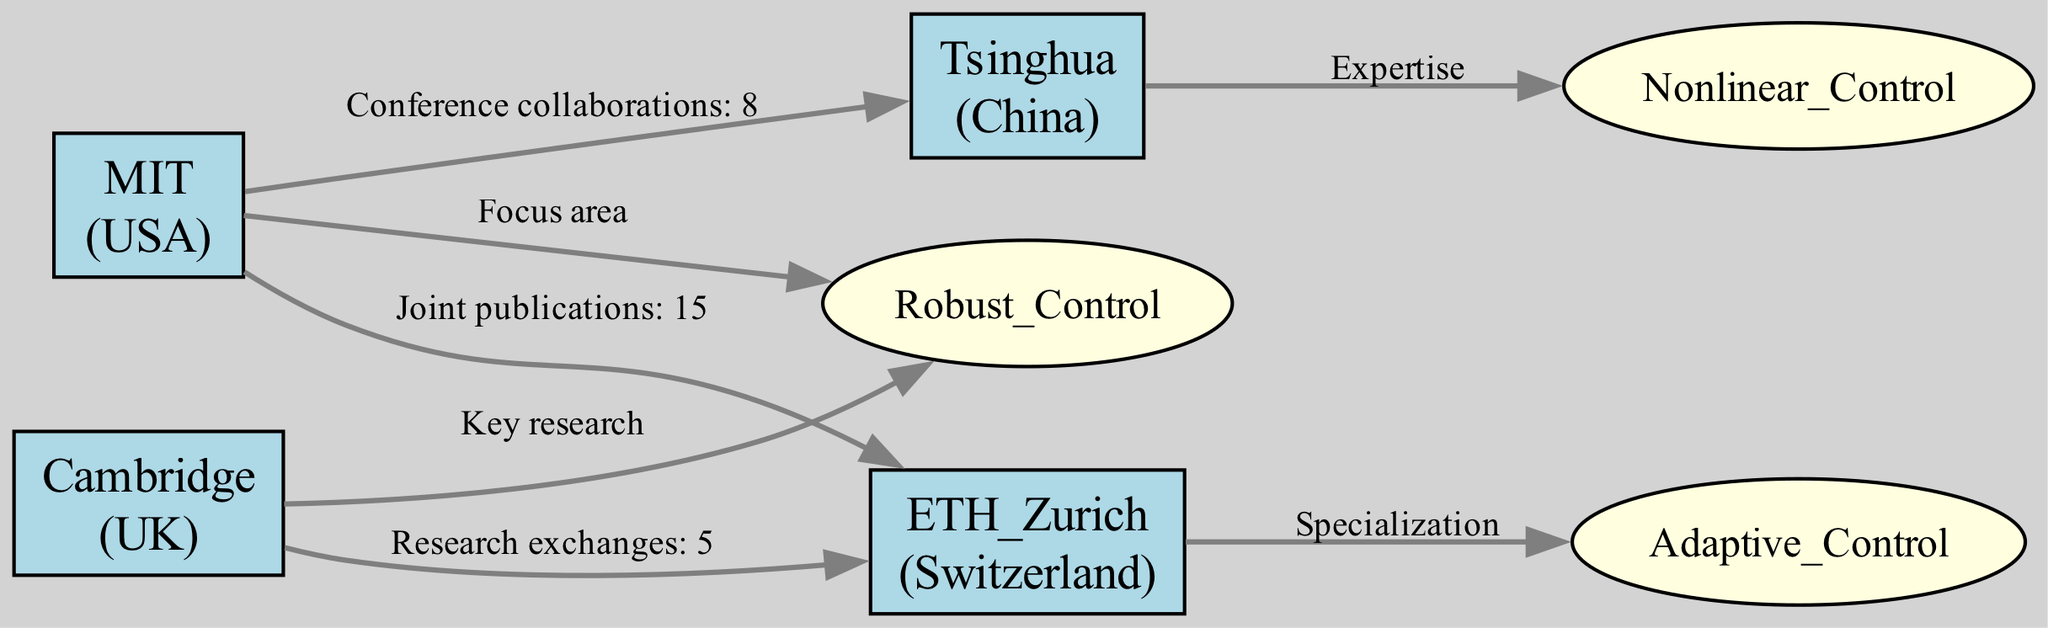What is the total number of universities represented in the diagram? There are four nodes labeled as universities: MIT, ETH Zurich, Tsinghua, and Cambridge. Counting these gives a total of 4 universities.
Answer: 4 Which university has the highest number of joint publications? The edge between MIT and ETH Zurich indicates 15 joint publications. Since this is the only joint publication noted, MIT has the highest with 15.
Answer: MIT How many research areas are represented in the diagram? There are three nodes labeled as research areas: Robust Control, Adaptive Control, and Nonlinear Control. Counting these gives a total of 3 research areas.
Answer: 3 Which university is associated with Robust Control? The edge from MIT to Robust Control labeled as "Focus area" shows that MIT is associated with Robust Control.
Answer: MIT What type of collaboration does Tsinghua have with MIT? The edge from MIT to Tsinghua labeled as "Conference collaborations: 8" indicates that their collaboration is based on conferences.
Answer: Conference collaborations Which two universities have the highest research involvement with each other? The edge between MIT and ETH Zurich indicates 15 joint publications, the highest numeric value of collaboration shown in the diagram. Therefore, MIT and ETH Zurich have the highest involvement.
Answer: MIT and ETH Zurich What specialization area is associated with ETH Zurich? The edge from ETH Zurich to Adaptive Control labeled as "Specialization" indicates that Adaptive Control is specifically associated with ETH Zurich.
Answer: Adaptive Control How many total collaborations are indicated between MIT and Tsinghua? The edge from MIT to Tsinghua indicates 8 conference collaborations, and this is the only collaboration mentioned in the diagram between these two institutions.
Answer: 8 